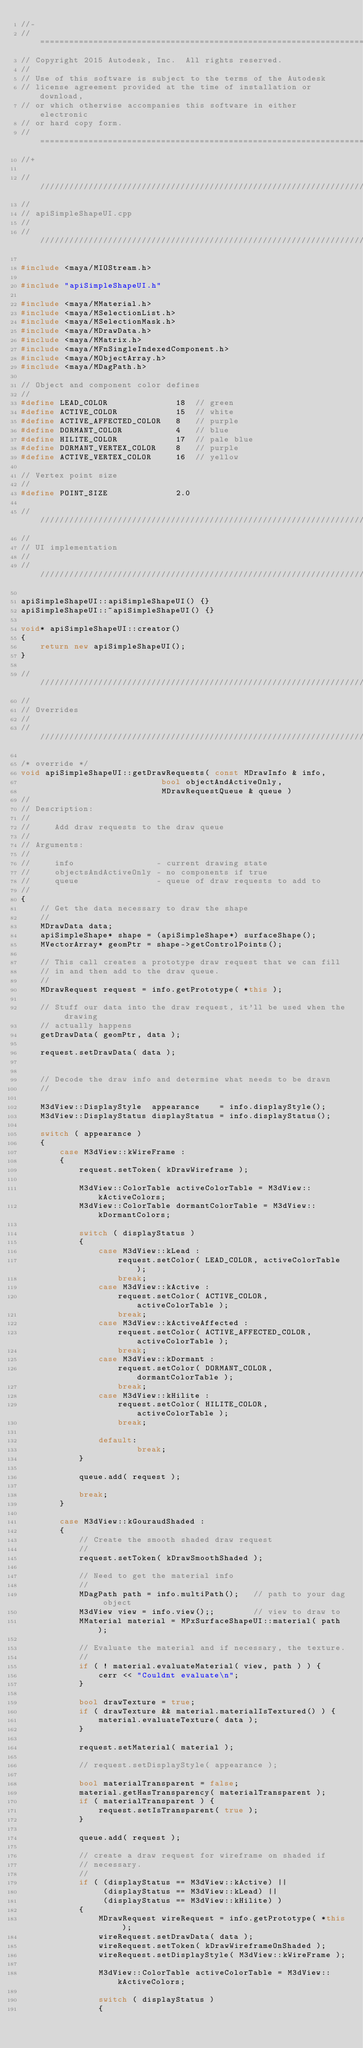Convert code to text. <code><loc_0><loc_0><loc_500><loc_500><_C++_>//-
// ==========================================================================
// Copyright 2015 Autodesk, Inc.  All rights reserved.
//
// Use of this software is subject to the terms of the Autodesk
// license agreement provided at the time of installation or download,
// or which otherwise accompanies this software in either electronic
// or hard copy form.
// ==========================================================================
//+

///////////////////////////////////////////////////////////////////////////////
//
// apiSimpleShapeUI.cpp
//
////////////////////////////////////////////////////////////////////////////////

#include <maya/MIOStream.h> 

#include "apiSimpleShapeUI.h"

#include <maya/MMaterial.h>
#include <maya/MSelectionList.h>
#include <maya/MSelectionMask.h>
#include <maya/MDrawData.h>
#include <maya/MMatrix.h>
#include <maya/MFnSingleIndexedComponent.h>
#include <maya/MObjectArray.h>
#include <maya/MDagPath.h>

// Object and component color defines
//
#define LEAD_COLOR				18	// green
#define ACTIVE_COLOR			15	// white
#define ACTIVE_AFFECTED_COLOR	8	// purple
#define DORMANT_COLOR			4	// blue
#define HILITE_COLOR			17	// pale blue
#define DORMANT_VERTEX_COLOR	8	// purple
#define ACTIVE_VERTEX_COLOR		16	// yellow

// Vertex point size
//
#define POINT_SIZE				2.0	

////////////////////////////////////////////////////////////////////////////////
//
// UI implementation
//
////////////////////////////////////////////////////////////////////////////////

apiSimpleShapeUI::apiSimpleShapeUI() {}
apiSimpleShapeUI::~apiSimpleShapeUI() {}

void* apiSimpleShapeUI::creator()
{
	return new apiSimpleShapeUI();
}

///////////////////////////////////////////////////////////////////////////////
//
// Overrides
//
///////////////////////////////////////////////////////////////////////////////

/* override */
void apiSimpleShapeUI::getDrawRequests( const MDrawInfo & info,
							 bool objectAndActiveOnly,
							 MDrawRequestQueue & queue )
//
// Description:
//
//     Add draw requests to the draw queue
//
// Arguments:
//
//     info                 - current drawing state
//     objectsAndActiveOnly - no components if true
//     queue                - queue of draw requests to add to
//
{
	// Get the data necessary to draw the shape
	//
	MDrawData data;
	apiSimpleShape* shape = (apiSimpleShape*) surfaceShape();
	MVectorArray* geomPtr = shape->getControlPoints();

	// This call creates a prototype draw request that we can fill
	// in and then add to the draw queue.
	//
	MDrawRequest request = info.getPrototype( *this );

	// Stuff our data into the draw request, it'll be used when the drawing
	// actually happens
	getDrawData( geomPtr, data );

	request.setDrawData( data );


	// Decode the draw info and determine what needs to be drawn
	//

	M3dView::DisplayStyle  appearance    = info.displayStyle();
	M3dView::DisplayStatus displayStatus = info.displayStatus();

	switch ( appearance )
	{
		case M3dView::kWireFrame :
		{
			request.setToken( kDrawWireframe );

			M3dView::ColorTable activeColorTable = M3dView::kActiveColors;
			M3dView::ColorTable dormantColorTable = M3dView::kDormantColors;

			switch ( displayStatus )
			{
				case M3dView::kLead :
					request.setColor( LEAD_COLOR, activeColorTable );
					break;
				case M3dView::kActive :
					request.setColor( ACTIVE_COLOR, activeColorTable );
					break;
				case M3dView::kActiveAffected :
					request.setColor( ACTIVE_AFFECTED_COLOR, activeColorTable );
					break;
				case M3dView::kDormant :
					request.setColor( DORMANT_COLOR, dormantColorTable );
					break;
				case M3dView::kHilite :
					request.setColor( HILITE_COLOR, activeColorTable );
					break;

				default:
						break;
			}

			queue.add( request );

			break;
		}

		case M3dView::kGouraudShaded :
		{
			// Create the smooth shaded draw request
			//
			request.setToken( kDrawSmoothShaded );

			// Need to get the material info
			//
			MDagPath path = info.multiPath();	// path to your dag object 
			M3dView view = info.view();; 		// view to draw to
			MMaterial material = MPxSurfaceShapeUI::material( path );

			// Evaluate the material and if necessary, the texture.
			//
			if ( ! material.evaluateMaterial( view, path ) ) {
				cerr << "Couldnt evaluate\n";
			}

			bool drawTexture = true;
			if ( drawTexture && material.materialIsTextured() ) {
				material.evaluateTexture( data );
			}

			request.setMaterial( material );

			// request.setDisplayStyle( appearance );

			bool materialTransparent = false;
			material.getHasTransparency( materialTransparent );
			if ( materialTransparent ) {
				request.setIsTransparent( true );
			}

			queue.add( request );

			// create a draw request for wireframe on shaded if
			// necessary.
			//
			if ( (displayStatus == M3dView::kActive) ||
				 (displayStatus == M3dView::kLead) ||
				 (displayStatus == M3dView::kHilite) )
			{
				MDrawRequest wireRequest = info.getPrototype( *this );
				wireRequest.setDrawData( data );
				wireRequest.setToken( kDrawWireframeOnShaded );
				wireRequest.setDisplayStyle( M3dView::kWireFrame );

				M3dView::ColorTable activeColorTable = M3dView::kActiveColors;

				switch ( displayStatus )
				{</code> 